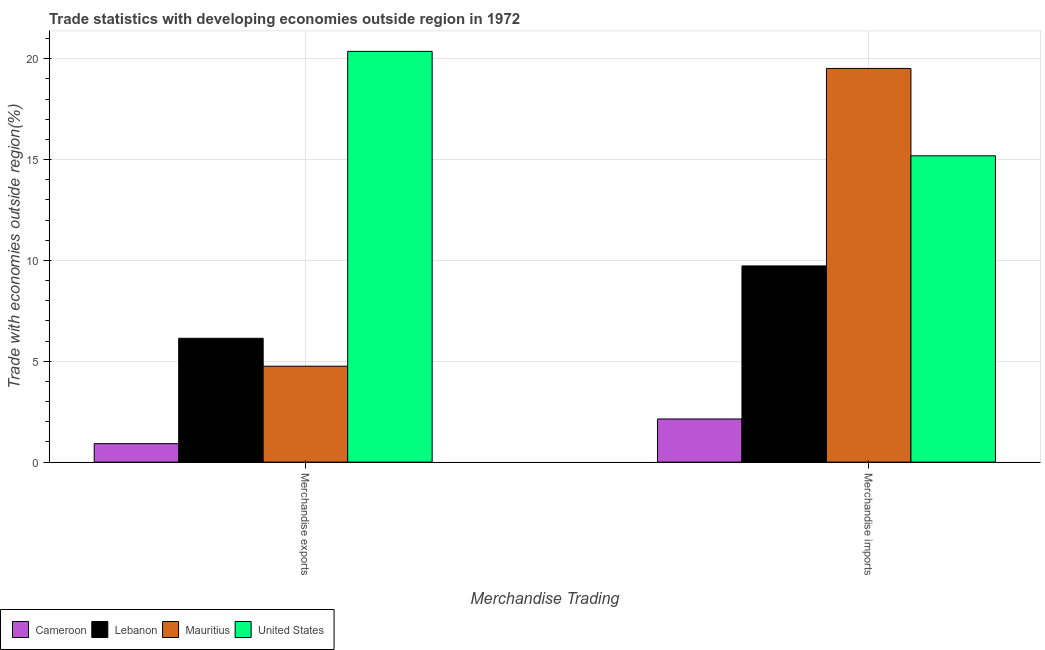Are the number of bars on each tick of the X-axis equal?
Give a very brief answer. Yes. How many bars are there on the 1st tick from the right?
Make the answer very short. 4. What is the merchandise exports in Mauritius?
Ensure brevity in your answer.  4.76. Across all countries, what is the maximum merchandise exports?
Give a very brief answer. 20.36. Across all countries, what is the minimum merchandise imports?
Offer a terse response. 2.14. In which country was the merchandise imports maximum?
Offer a terse response. Mauritius. In which country was the merchandise exports minimum?
Ensure brevity in your answer.  Cameroon. What is the total merchandise exports in the graph?
Provide a short and direct response. 32.17. What is the difference between the merchandise exports in Mauritius and that in Cameroon?
Keep it short and to the point. 3.84. What is the difference between the merchandise imports in Cameroon and the merchandise exports in Mauritius?
Offer a very short reply. -2.62. What is the average merchandise exports per country?
Ensure brevity in your answer.  8.04. What is the difference between the merchandise exports and merchandise imports in Lebanon?
Your answer should be very brief. -3.59. What is the ratio of the merchandise imports in Cameroon to that in United States?
Your answer should be very brief. 0.14. What does the 2nd bar from the right in Merchandise exports represents?
Make the answer very short. Mauritius. How many bars are there?
Keep it short and to the point. 8. How many countries are there in the graph?
Your response must be concise. 4. What is the difference between two consecutive major ticks on the Y-axis?
Your answer should be very brief. 5. Does the graph contain any zero values?
Give a very brief answer. No. Where does the legend appear in the graph?
Your response must be concise. Bottom left. What is the title of the graph?
Your response must be concise. Trade statistics with developing economies outside region in 1972. Does "Czech Republic" appear as one of the legend labels in the graph?
Provide a short and direct response. No. What is the label or title of the X-axis?
Offer a terse response. Merchandise Trading. What is the label or title of the Y-axis?
Offer a terse response. Trade with economies outside region(%). What is the Trade with economies outside region(%) in Cameroon in Merchandise exports?
Give a very brief answer. 0.92. What is the Trade with economies outside region(%) of Lebanon in Merchandise exports?
Provide a short and direct response. 6.14. What is the Trade with economies outside region(%) in Mauritius in Merchandise exports?
Your response must be concise. 4.76. What is the Trade with economies outside region(%) in United States in Merchandise exports?
Provide a short and direct response. 20.36. What is the Trade with economies outside region(%) of Cameroon in Merchandise imports?
Your answer should be very brief. 2.14. What is the Trade with economies outside region(%) of Lebanon in Merchandise imports?
Give a very brief answer. 9.73. What is the Trade with economies outside region(%) in Mauritius in Merchandise imports?
Make the answer very short. 19.52. What is the Trade with economies outside region(%) in United States in Merchandise imports?
Keep it short and to the point. 15.19. Across all Merchandise Trading, what is the maximum Trade with economies outside region(%) of Cameroon?
Give a very brief answer. 2.14. Across all Merchandise Trading, what is the maximum Trade with economies outside region(%) in Lebanon?
Make the answer very short. 9.73. Across all Merchandise Trading, what is the maximum Trade with economies outside region(%) of Mauritius?
Offer a very short reply. 19.52. Across all Merchandise Trading, what is the maximum Trade with economies outside region(%) of United States?
Make the answer very short. 20.36. Across all Merchandise Trading, what is the minimum Trade with economies outside region(%) of Cameroon?
Your answer should be very brief. 0.92. Across all Merchandise Trading, what is the minimum Trade with economies outside region(%) of Lebanon?
Ensure brevity in your answer.  6.14. Across all Merchandise Trading, what is the minimum Trade with economies outside region(%) of Mauritius?
Keep it short and to the point. 4.76. Across all Merchandise Trading, what is the minimum Trade with economies outside region(%) of United States?
Your answer should be compact. 15.19. What is the total Trade with economies outside region(%) of Cameroon in the graph?
Provide a short and direct response. 3.05. What is the total Trade with economies outside region(%) in Lebanon in the graph?
Make the answer very short. 15.87. What is the total Trade with economies outside region(%) of Mauritius in the graph?
Offer a terse response. 24.27. What is the total Trade with economies outside region(%) in United States in the graph?
Provide a short and direct response. 35.55. What is the difference between the Trade with economies outside region(%) in Cameroon in Merchandise exports and that in Merchandise imports?
Your response must be concise. -1.22. What is the difference between the Trade with economies outside region(%) of Lebanon in Merchandise exports and that in Merchandise imports?
Keep it short and to the point. -3.59. What is the difference between the Trade with economies outside region(%) in Mauritius in Merchandise exports and that in Merchandise imports?
Provide a short and direct response. -14.76. What is the difference between the Trade with economies outside region(%) of United States in Merchandise exports and that in Merchandise imports?
Your response must be concise. 5.18. What is the difference between the Trade with economies outside region(%) in Cameroon in Merchandise exports and the Trade with economies outside region(%) in Lebanon in Merchandise imports?
Provide a short and direct response. -8.81. What is the difference between the Trade with economies outside region(%) in Cameroon in Merchandise exports and the Trade with economies outside region(%) in Mauritius in Merchandise imports?
Provide a succinct answer. -18.6. What is the difference between the Trade with economies outside region(%) of Cameroon in Merchandise exports and the Trade with economies outside region(%) of United States in Merchandise imports?
Keep it short and to the point. -14.27. What is the difference between the Trade with economies outside region(%) of Lebanon in Merchandise exports and the Trade with economies outside region(%) of Mauritius in Merchandise imports?
Make the answer very short. -13.38. What is the difference between the Trade with economies outside region(%) in Lebanon in Merchandise exports and the Trade with economies outside region(%) in United States in Merchandise imports?
Provide a short and direct response. -9.05. What is the difference between the Trade with economies outside region(%) in Mauritius in Merchandise exports and the Trade with economies outside region(%) in United States in Merchandise imports?
Keep it short and to the point. -10.43. What is the average Trade with economies outside region(%) of Cameroon per Merchandise Trading?
Your response must be concise. 1.53. What is the average Trade with economies outside region(%) in Lebanon per Merchandise Trading?
Offer a very short reply. 7.93. What is the average Trade with economies outside region(%) of Mauritius per Merchandise Trading?
Provide a succinct answer. 12.14. What is the average Trade with economies outside region(%) of United States per Merchandise Trading?
Make the answer very short. 17.78. What is the difference between the Trade with economies outside region(%) of Cameroon and Trade with economies outside region(%) of Lebanon in Merchandise exports?
Your answer should be very brief. -5.22. What is the difference between the Trade with economies outside region(%) of Cameroon and Trade with economies outside region(%) of Mauritius in Merchandise exports?
Keep it short and to the point. -3.84. What is the difference between the Trade with economies outside region(%) in Cameroon and Trade with economies outside region(%) in United States in Merchandise exports?
Give a very brief answer. -19.45. What is the difference between the Trade with economies outside region(%) of Lebanon and Trade with economies outside region(%) of Mauritius in Merchandise exports?
Provide a succinct answer. 1.38. What is the difference between the Trade with economies outside region(%) in Lebanon and Trade with economies outside region(%) in United States in Merchandise exports?
Your response must be concise. -14.22. What is the difference between the Trade with economies outside region(%) of Mauritius and Trade with economies outside region(%) of United States in Merchandise exports?
Your answer should be very brief. -15.61. What is the difference between the Trade with economies outside region(%) in Cameroon and Trade with economies outside region(%) in Lebanon in Merchandise imports?
Your answer should be very brief. -7.59. What is the difference between the Trade with economies outside region(%) of Cameroon and Trade with economies outside region(%) of Mauritius in Merchandise imports?
Provide a succinct answer. -17.38. What is the difference between the Trade with economies outside region(%) in Cameroon and Trade with economies outside region(%) in United States in Merchandise imports?
Provide a short and direct response. -13.05. What is the difference between the Trade with economies outside region(%) of Lebanon and Trade with economies outside region(%) of Mauritius in Merchandise imports?
Make the answer very short. -9.79. What is the difference between the Trade with economies outside region(%) of Lebanon and Trade with economies outside region(%) of United States in Merchandise imports?
Your answer should be very brief. -5.46. What is the difference between the Trade with economies outside region(%) of Mauritius and Trade with economies outside region(%) of United States in Merchandise imports?
Offer a very short reply. 4.33. What is the ratio of the Trade with economies outside region(%) of Cameroon in Merchandise exports to that in Merchandise imports?
Provide a short and direct response. 0.43. What is the ratio of the Trade with economies outside region(%) in Lebanon in Merchandise exports to that in Merchandise imports?
Your response must be concise. 0.63. What is the ratio of the Trade with economies outside region(%) of Mauritius in Merchandise exports to that in Merchandise imports?
Provide a short and direct response. 0.24. What is the ratio of the Trade with economies outside region(%) of United States in Merchandise exports to that in Merchandise imports?
Keep it short and to the point. 1.34. What is the difference between the highest and the second highest Trade with economies outside region(%) in Cameroon?
Offer a terse response. 1.22. What is the difference between the highest and the second highest Trade with economies outside region(%) in Lebanon?
Give a very brief answer. 3.59. What is the difference between the highest and the second highest Trade with economies outside region(%) of Mauritius?
Provide a short and direct response. 14.76. What is the difference between the highest and the second highest Trade with economies outside region(%) of United States?
Keep it short and to the point. 5.18. What is the difference between the highest and the lowest Trade with economies outside region(%) in Cameroon?
Offer a very short reply. 1.22. What is the difference between the highest and the lowest Trade with economies outside region(%) of Lebanon?
Make the answer very short. 3.59. What is the difference between the highest and the lowest Trade with economies outside region(%) in Mauritius?
Make the answer very short. 14.76. What is the difference between the highest and the lowest Trade with economies outside region(%) of United States?
Keep it short and to the point. 5.18. 